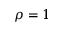<formula> <loc_0><loc_0><loc_500><loc_500>\rho = 1</formula> 